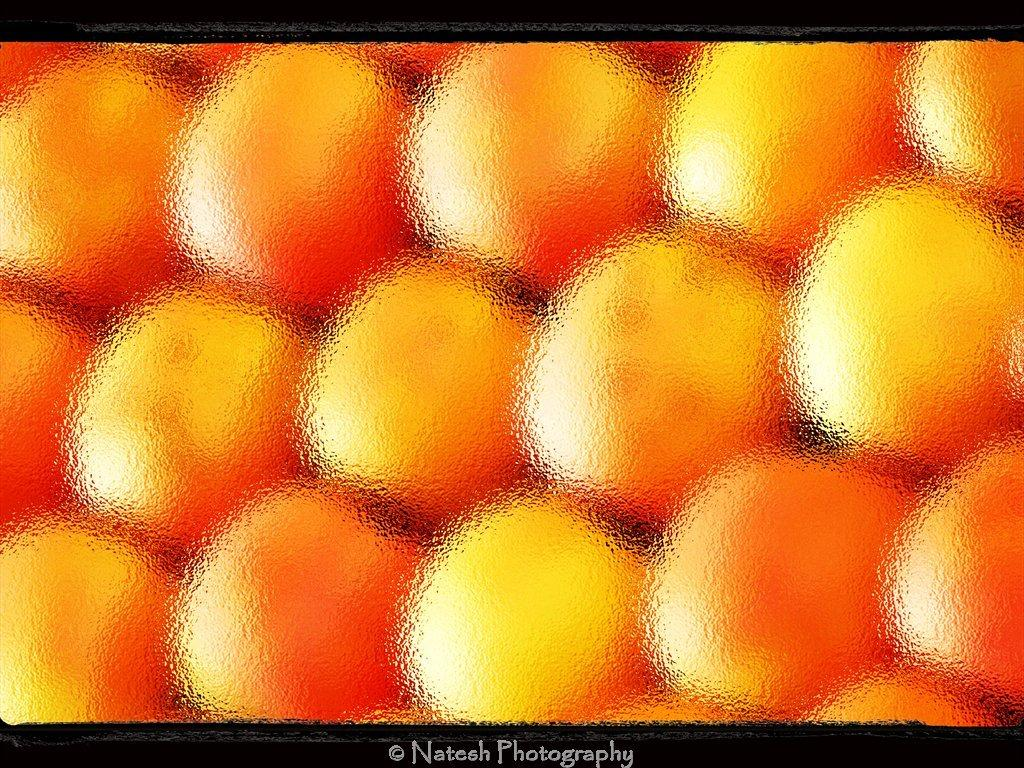What is the main subject of the image? The main subject of the image appears to be oranges. How would you describe the appearance of the oranges in the image? The oranges are blurred in the image. Is there any text present in the image? Yes, there is text at the bottom of the image. What type of vessel is used to transport the oranges in the image? There is no vessel present in the image, as it only depicts oranges and text. Can you tell me how many wrenches are visible in the image? There are no wrenches present in the image; it only features oranges and text. 